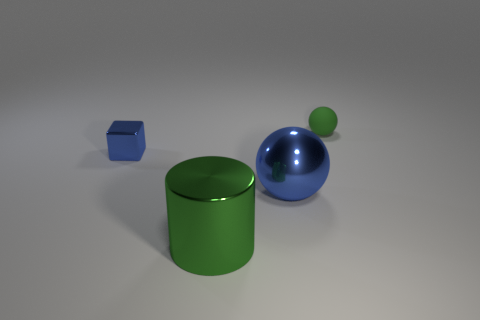Can you tell me the colors of the objects in the image? Certainly! In the image, we have a blue block, a green cylinder, a larger blue sphere, and a smaller green sphere. 